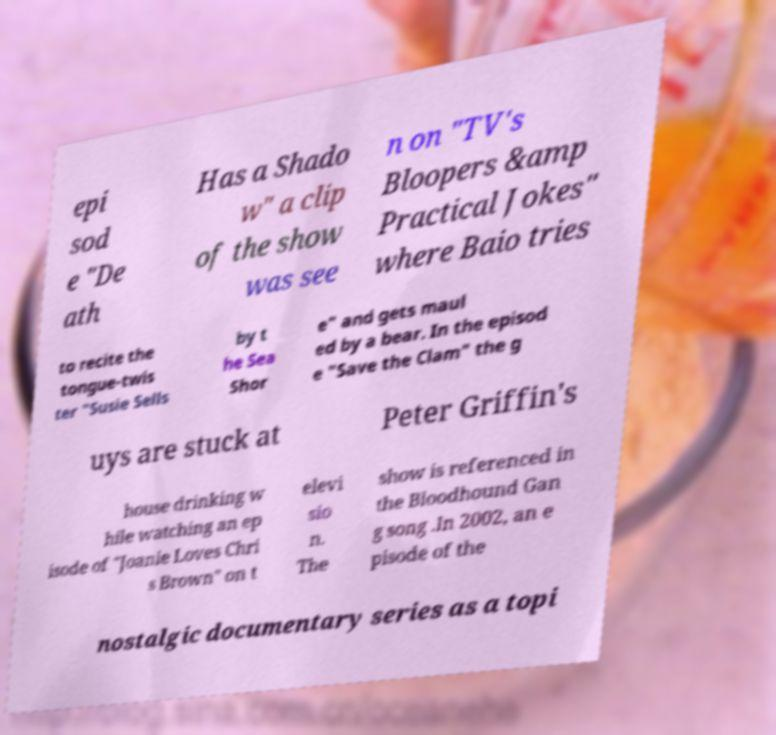What messages or text are displayed in this image? I need them in a readable, typed format. epi sod e "De ath Has a Shado w" a clip of the show was see n on "TV's Bloopers &amp Practical Jokes" where Baio tries to recite the tongue-twis ter "Susie Sells by t he Sea Shor e" and gets maul ed by a bear. In the episod e "Save the Clam" the g uys are stuck at Peter Griffin's house drinking w hile watching an ep isode of "Joanie Loves Chri s Brown" on t elevi sio n. The show is referenced in the Bloodhound Gan g song .In 2002, an e pisode of the nostalgic documentary series as a topi 